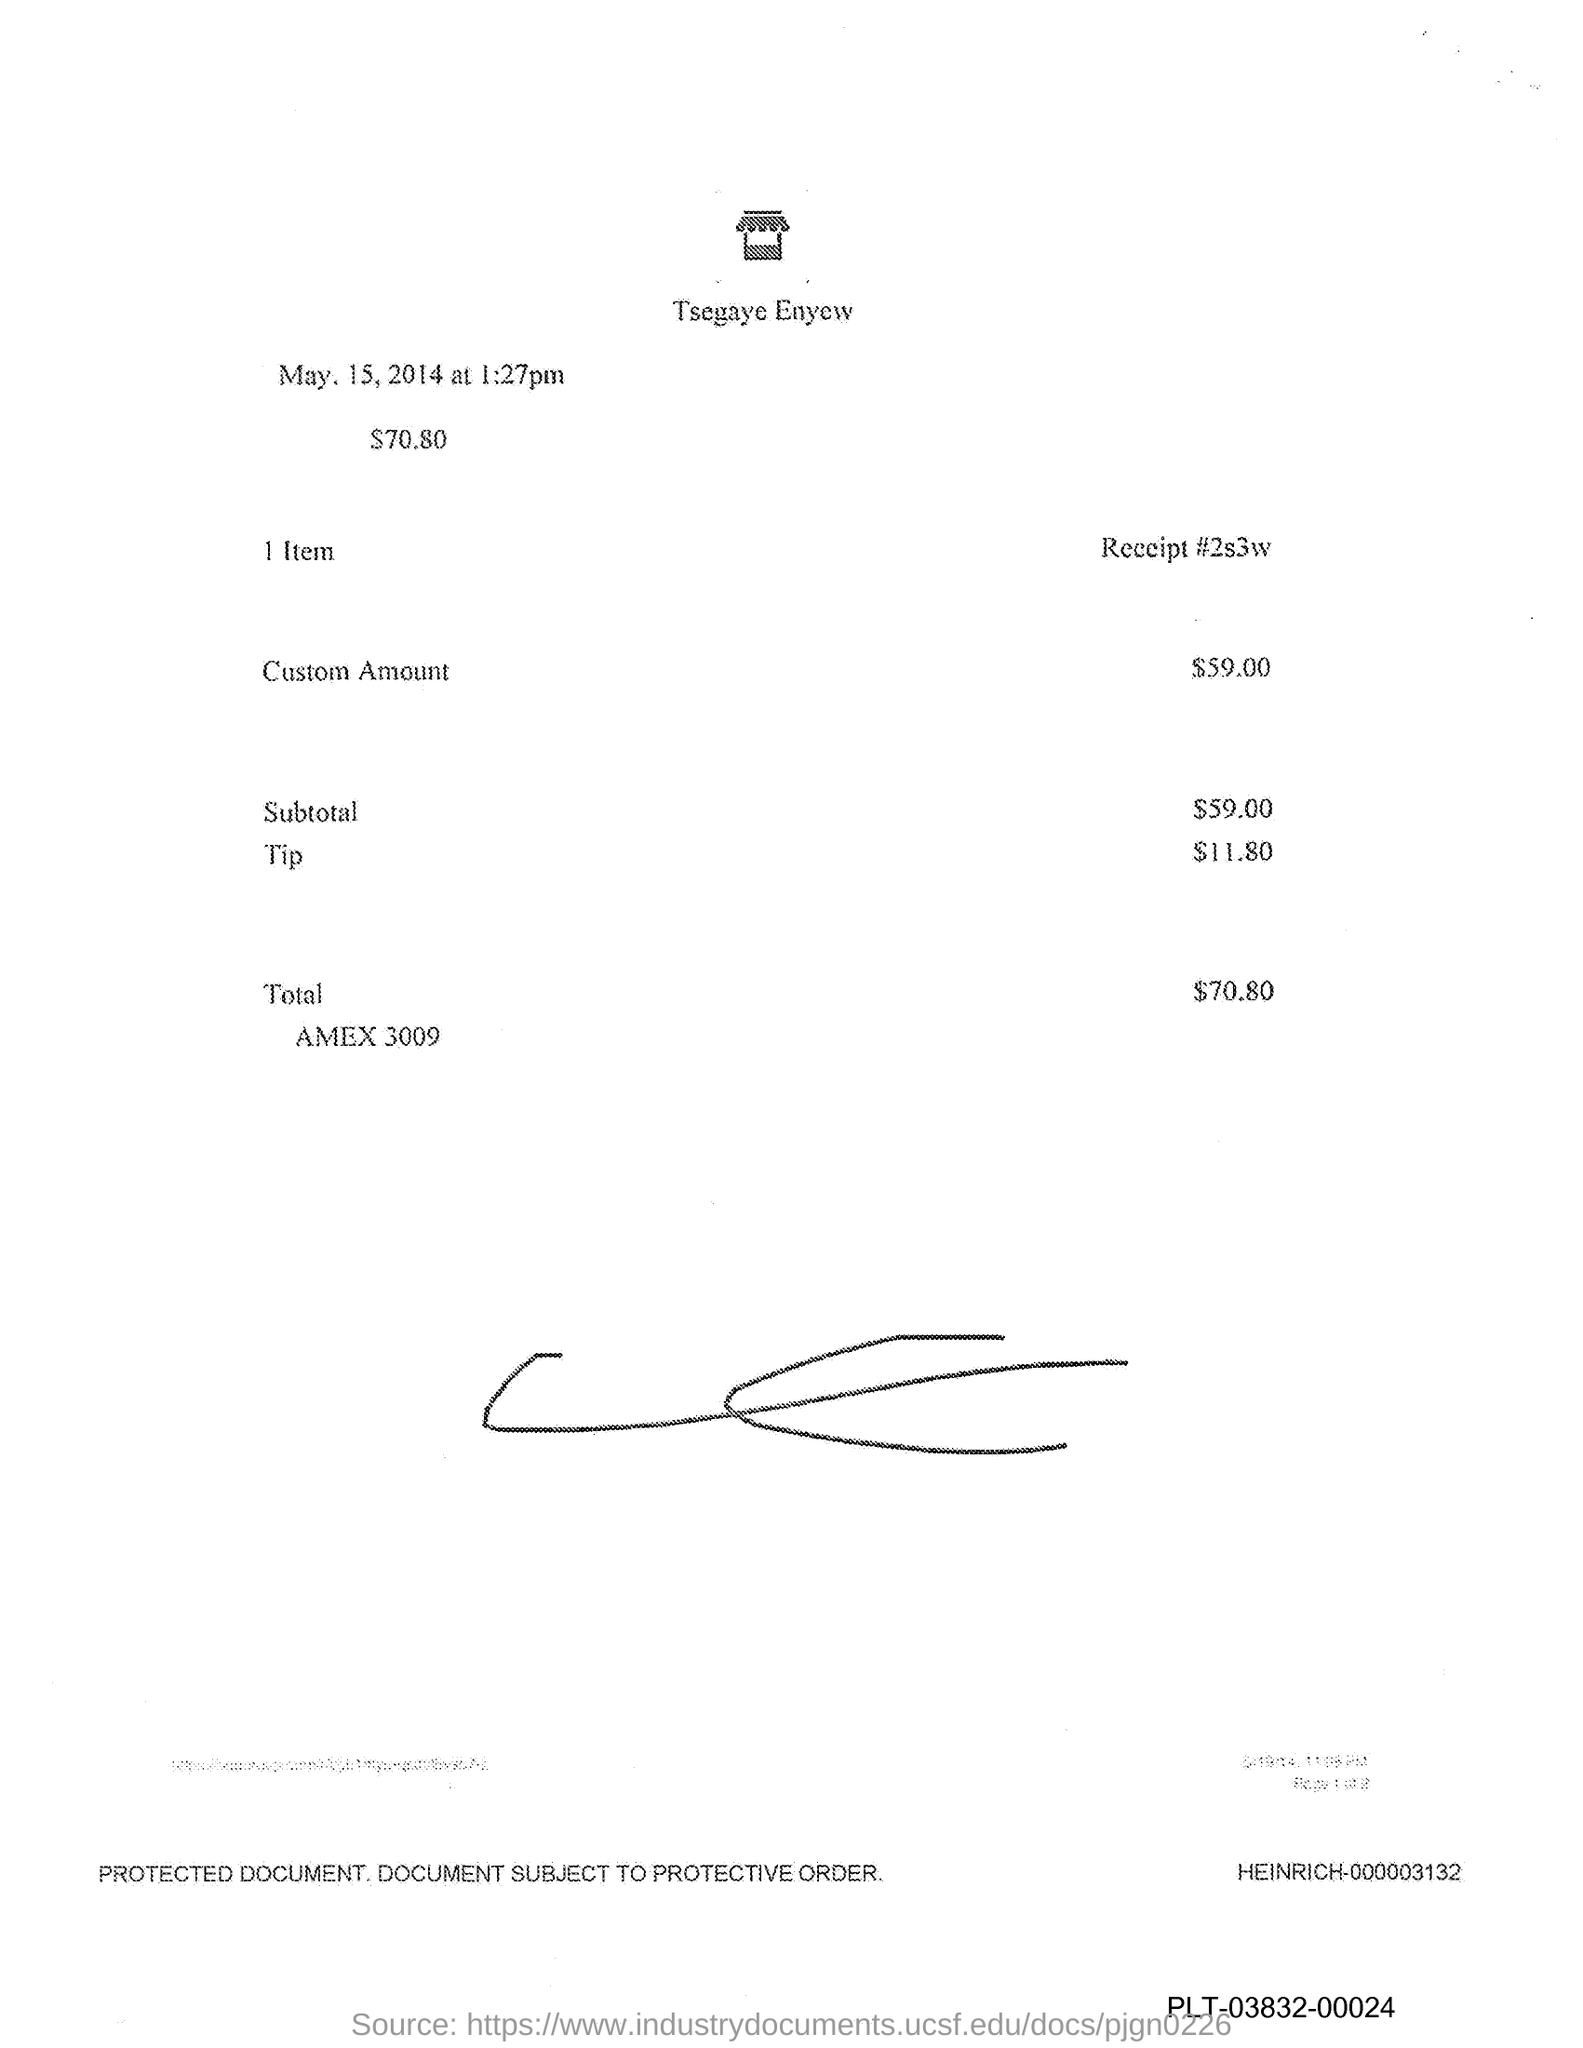What is the custom amount given in the document?
Your answer should be very brief. $59.00. How much is the tip mentioned in the document?
Provide a short and direct response. $11.80. 